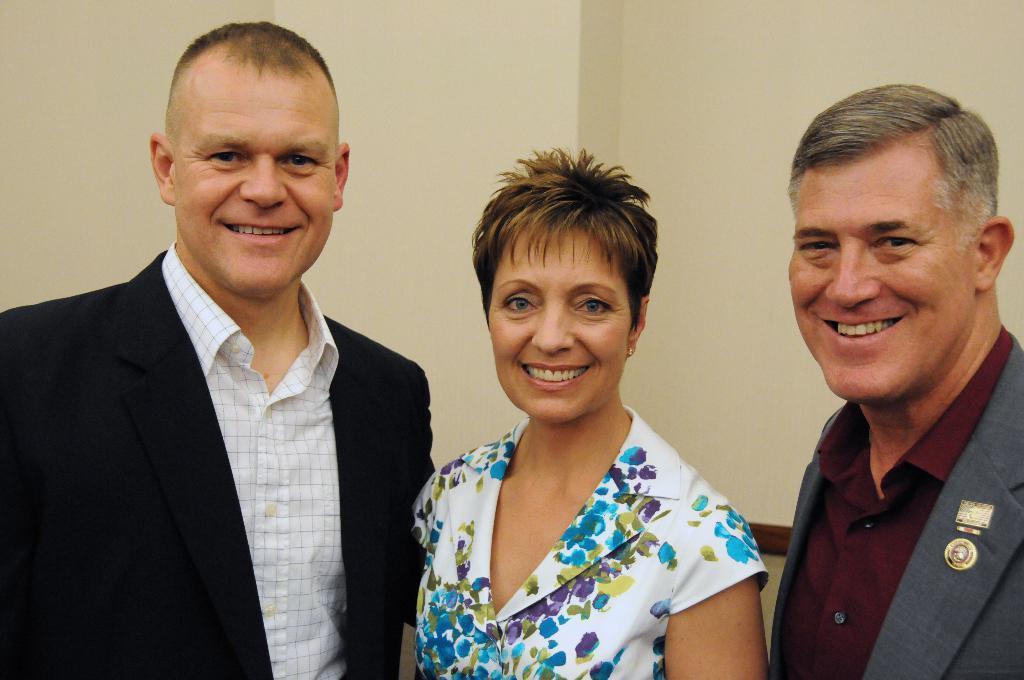Can you describe this image briefly? In this image I can see a woman and two men. I can also see smile on their faces and I can see these two are wearing shirt and blazers. I can also see she is wearing white colour dress. 